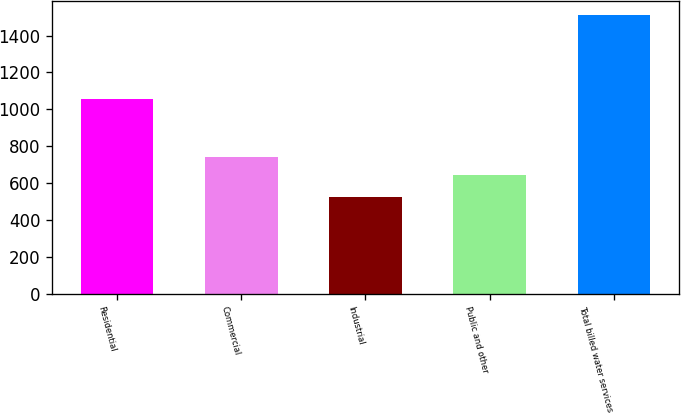<chart> <loc_0><loc_0><loc_500><loc_500><bar_chart><fcel>Residential<fcel>Commercial<fcel>Industrial<fcel>Public and other<fcel>Total billed water services<nl><fcel>1054<fcel>744.3<fcel>526<fcel>646<fcel>1509<nl></chart> 